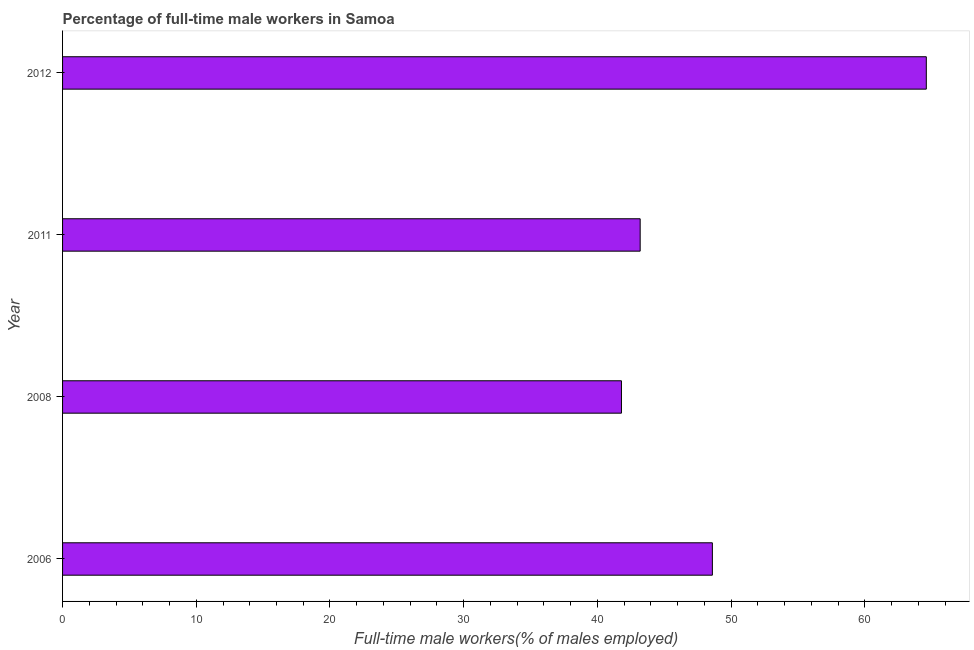Does the graph contain any zero values?
Offer a terse response. No. What is the title of the graph?
Your answer should be very brief. Percentage of full-time male workers in Samoa. What is the label or title of the X-axis?
Offer a very short reply. Full-time male workers(% of males employed). What is the percentage of full-time male workers in 2006?
Offer a terse response. 48.6. Across all years, what is the maximum percentage of full-time male workers?
Your response must be concise. 64.6. Across all years, what is the minimum percentage of full-time male workers?
Provide a short and direct response. 41.8. What is the sum of the percentage of full-time male workers?
Offer a very short reply. 198.2. What is the difference between the percentage of full-time male workers in 2011 and 2012?
Keep it short and to the point. -21.4. What is the average percentage of full-time male workers per year?
Offer a very short reply. 49.55. What is the median percentage of full-time male workers?
Offer a terse response. 45.9. In how many years, is the percentage of full-time male workers greater than 48 %?
Your answer should be compact. 2. What is the ratio of the percentage of full-time male workers in 2008 to that in 2012?
Provide a succinct answer. 0.65. Is the percentage of full-time male workers in 2011 less than that in 2012?
Offer a very short reply. Yes. Is the sum of the percentage of full-time male workers in 2008 and 2012 greater than the maximum percentage of full-time male workers across all years?
Your answer should be very brief. Yes. What is the difference between the highest and the lowest percentage of full-time male workers?
Provide a short and direct response. 22.8. How many bars are there?
Offer a terse response. 4. Are all the bars in the graph horizontal?
Keep it short and to the point. Yes. How many years are there in the graph?
Your answer should be very brief. 4. What is the Full-time male workers(% of males employed) of 2006?
Offer a terse response. 48.6. What is the Full-time male workers(% of males employed) in 2008?
Provide a succinct answer. 41.8. What is the Full-time male workers(% of males employed) in 2011?
Make the answer very short. 43.2. What is the Full-time male workers(% of males employed) of 2012?
Provide a short and direct response. 64.6. What is the difference between the Full-time male workers(% of males employed) in 2006 and 2008?
Your answer should be compact. 6.8. What is the difference between the Full-time male workers(% of males employed) in 2006 and 2011?
Give a very brief answer. 5.4. What is the difference between the Full-time male workers(% of males employed) in 2006 and 2012?
Provide a succinct answer. -16. What is the difference between the Full-time male workers(% of males employed) in 2008 and 2011?
Your answer should be compact. -1.4. What is the difference between the Full-time male workers(% of males employed) in 2008 and 2012?
Offer a very short reply. -22.8. What is the difference between the Full-time male workers(% of males employed) in 2011 and 2012?
Ensure brevity in your answer.  -21.4. What is the ratio of the Full-time male workers(% of males employed) in 2006 to that in 2008?
Provide a succinct answer. 1.16. What is the ratio of the Full-time male workers(% of males employed) in 2006 to that in 2012?
Provide a succinct answer. 0.75. What is the ratio of the Full-time male workers(% of males employed) in 2008 to that in 2011?
Provide a succinct answer. 0.97. What is the ratio of the Full-time male workers(% of males employed) in 2008 to that in 2012?
Your answer should be compact. 0.65. What is the ratio of the Full-time male workers(% of males employed) in 2011 to that in 2012?
Your answer should be compact. 0.67. 